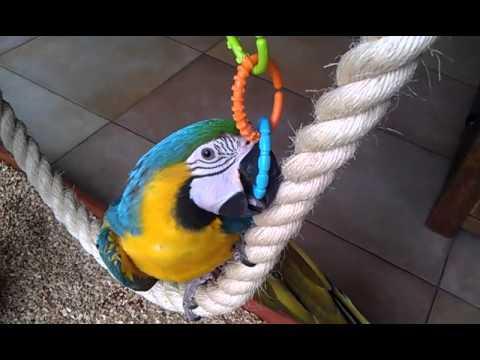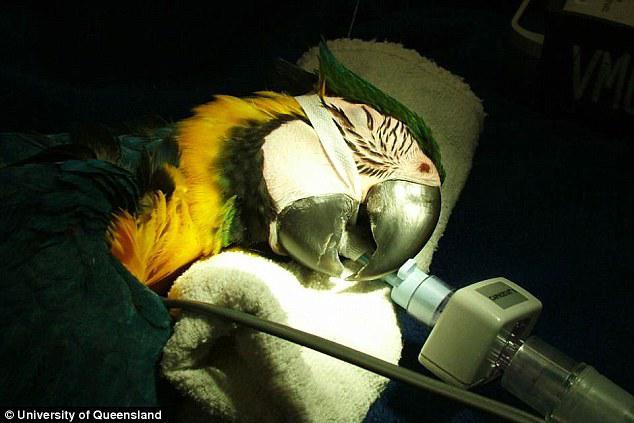The first image is the image on the left, the second image is the image on the right. Considering the images on both sides, is "The macaws are all on their feet." valid? Answer yes or no. No. The first image is the image on the left, the second image is the image on the right. Considering the images on both sides, is "There are plastic rings linked" valid? Answer yes or no. Yes. 